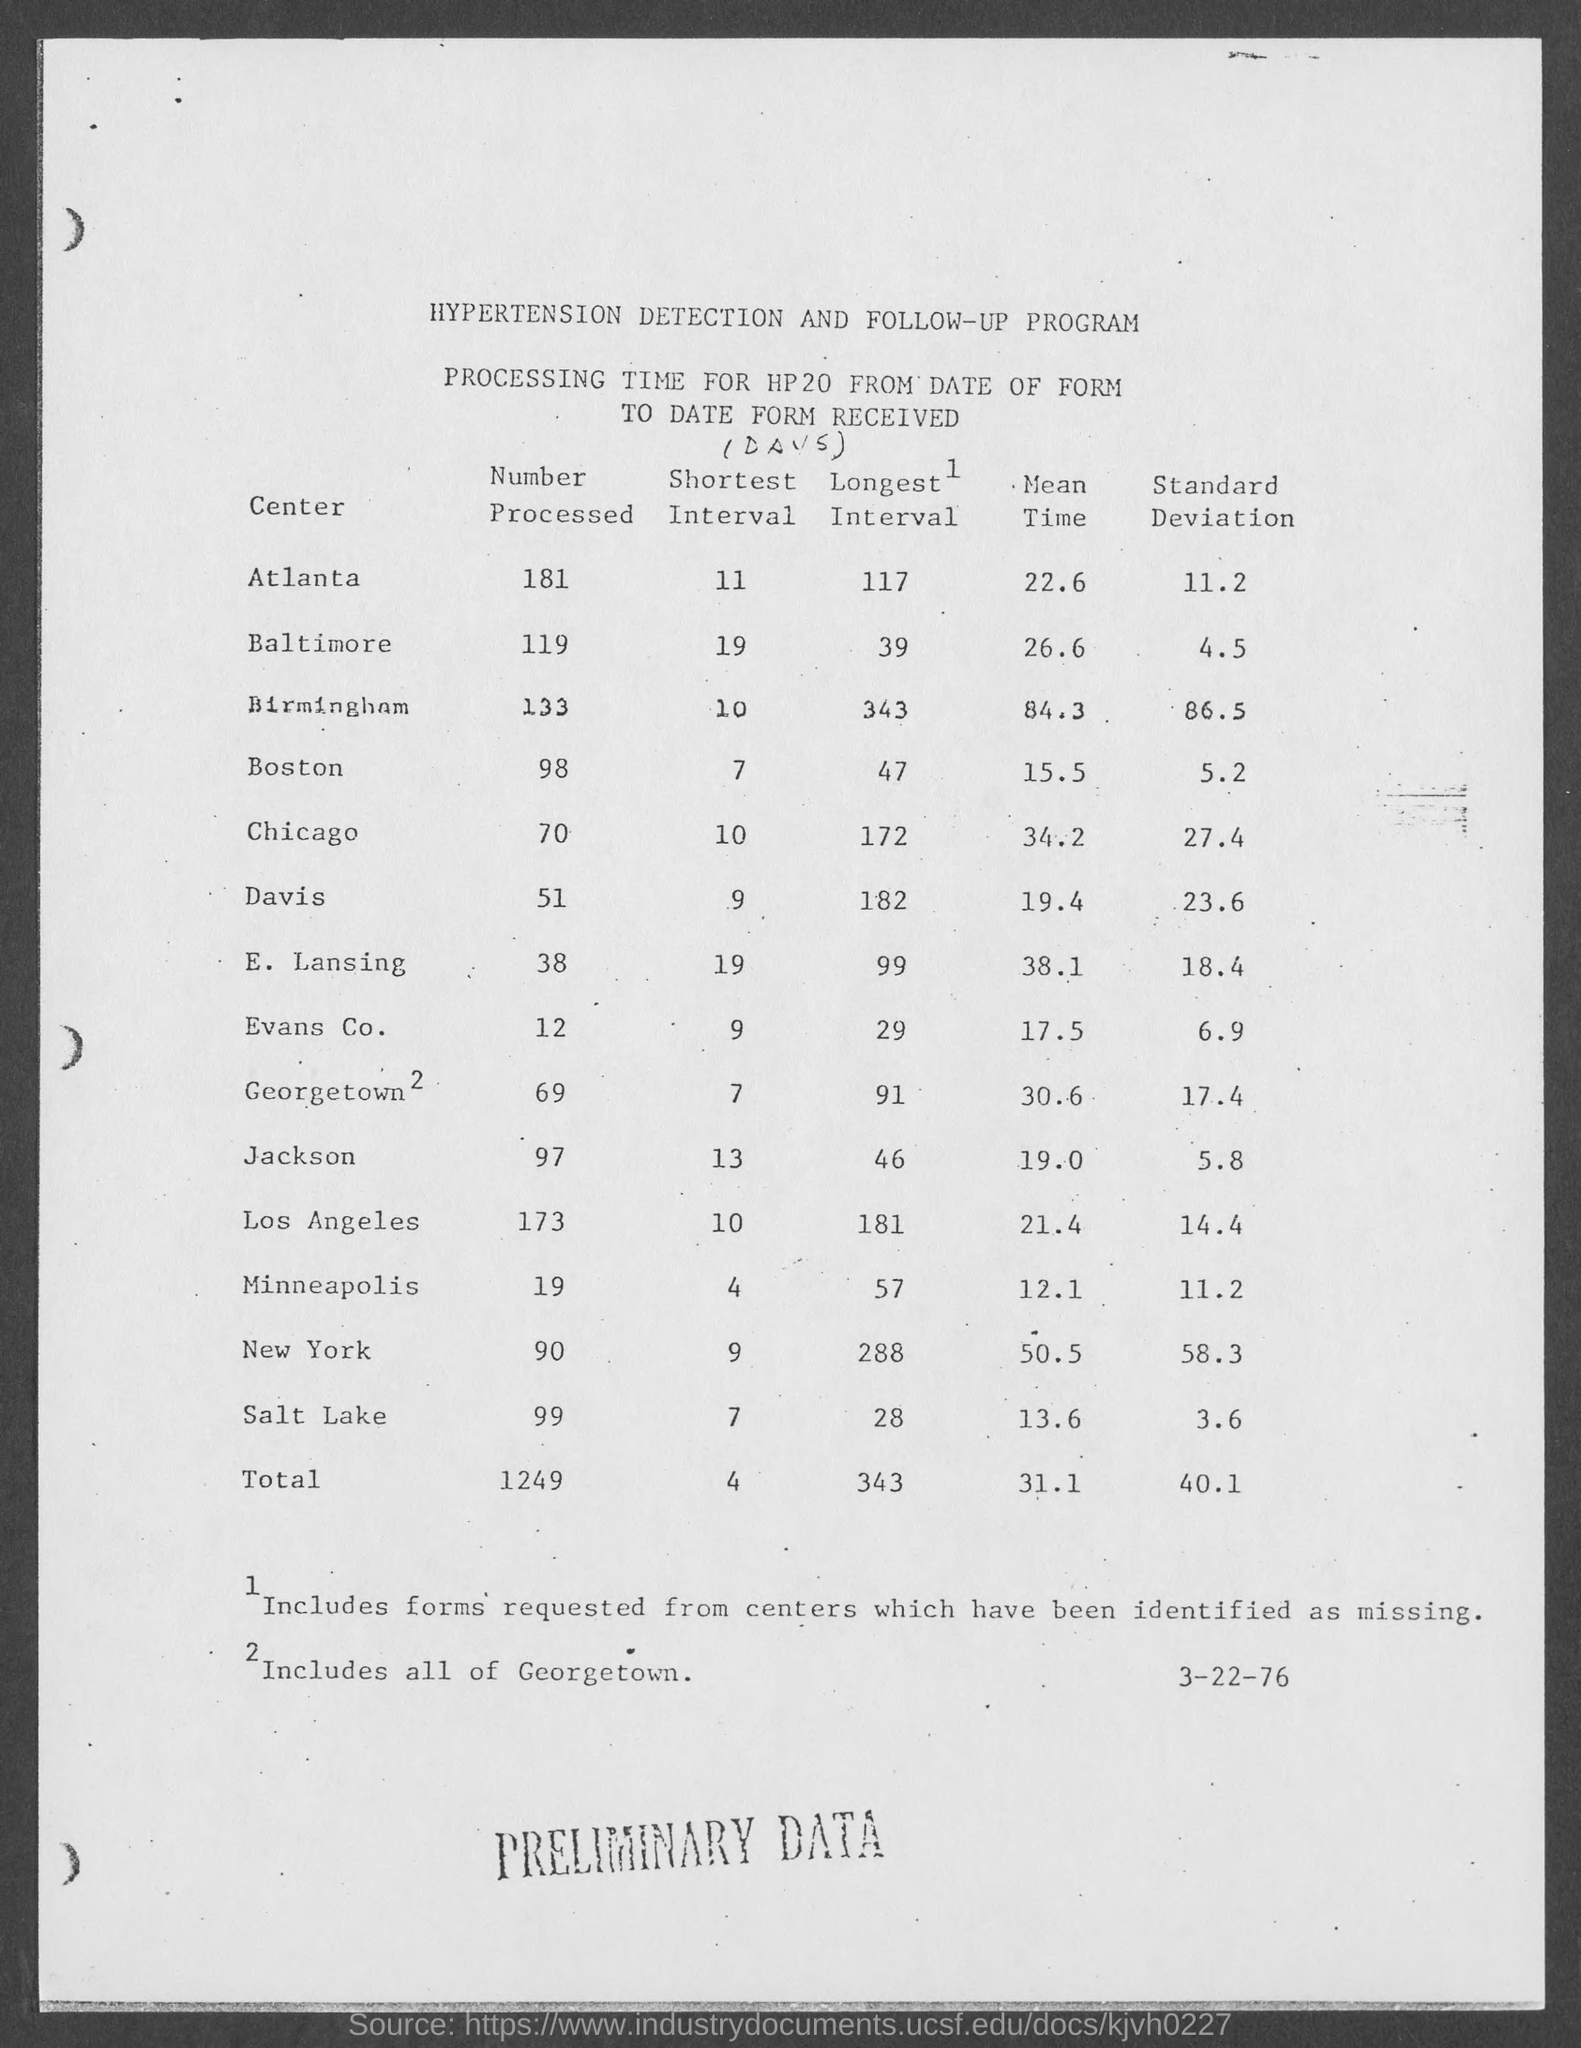Mention a couple of crucial points in this snapshot. The total number processed from all the centers is 1,249. The mean time for Boston, based on the table, is 15.5.. The standard deviation for Atlanta in the table is 11.2. The last column heading of the table is "Standard Deviation. What is the shortest interval for Baltimore in the table? 19.." is a question asking for the shortest amount of time that Baltimore is expected to hold a lead in the given data. 